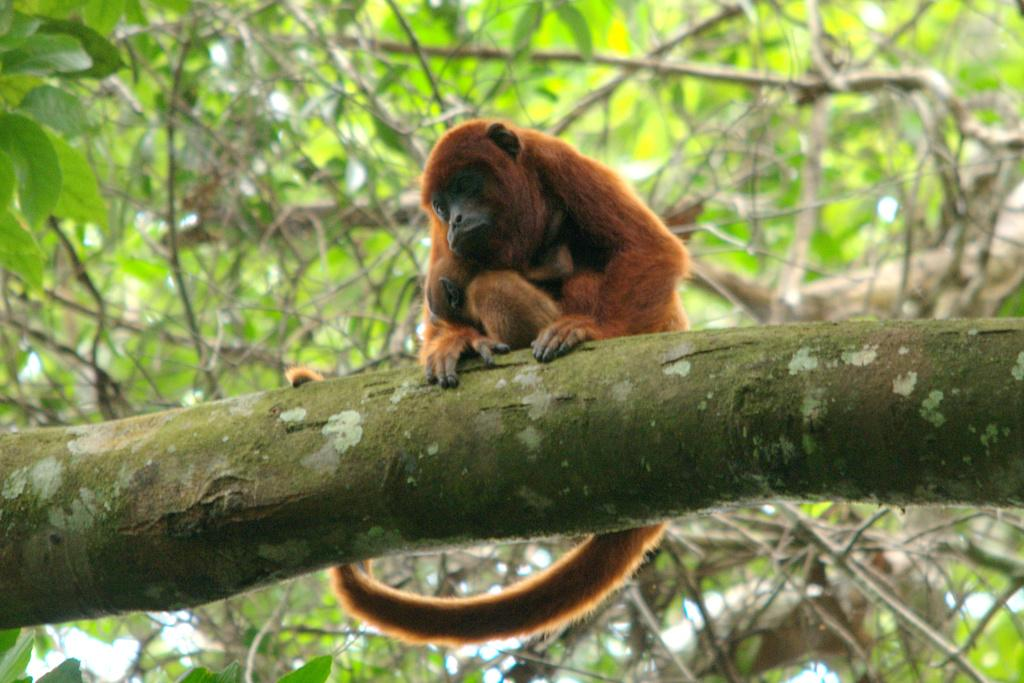What is placed on a branch in the image? There is money on a branch in the image. Can you describe the monkey in the image? The monkey is in brown color. What can be seen in the background of the image? There are trees in the background of the image. What is the color of the trees in the image? The trees are green in color. What type of zinc is the monkey using to climb the tree in the image? There is no zinc present in the image, and the monkey is not using any zinc to climb the tree. 